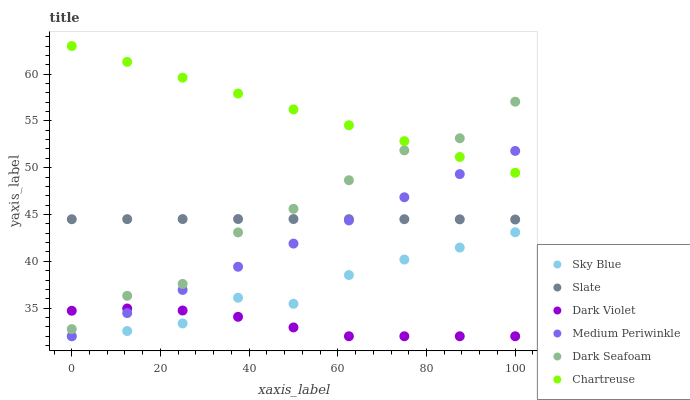Does Dark Violet have the minimum area under the curve?
Answer yes or no. Yes. Does Chartreuse have the maximum area under the curve?
Answer yes or no. Yes. Does Medium Periwinkle have the minimum area under the curve?
Answer yes or no. No. Does Medium Periwinkle have the maximum area under the curve?
Answer yes or no. No. Is Chartreuse the smoothest?
Answer yes or no. Yes. Is Dark Seafoam the roughest?
Answer yes or no. Yes. Is Medium Periwinkle the smoothest?
Answer yes or no. No. Is Medium Periwinkle the roughest?
Answer yes or no. No. Does Medium Periwinkle have the lowest value?
Answer yes or no. Yes. Does Chartreuse have the lowest value?
Answer yes or no. No. Does Chartreuse have the highest value?
Answer yes or no. Yes. Does Medium Periwinkle have the highest value?
Answer yes or no. No. Is Medium Periwinkle less than Dark Seafoam?
Answer yes or no. Yes. Is Dark Seafoam greater than Sky Blue?
Answer yes or no. Yes. Does Medium Periwinkle intersect Dark Violet?
Answer yes or no. Yes. Is Medium Periwinkle less than Dark Violet?
Answer yes or no. No. Is Medium Periwinkle greater than Dark Violet?
Answer yes or no. No. Does Medium Periwinkle intersect Dark Seafoam?
Answer yes or no. No. 